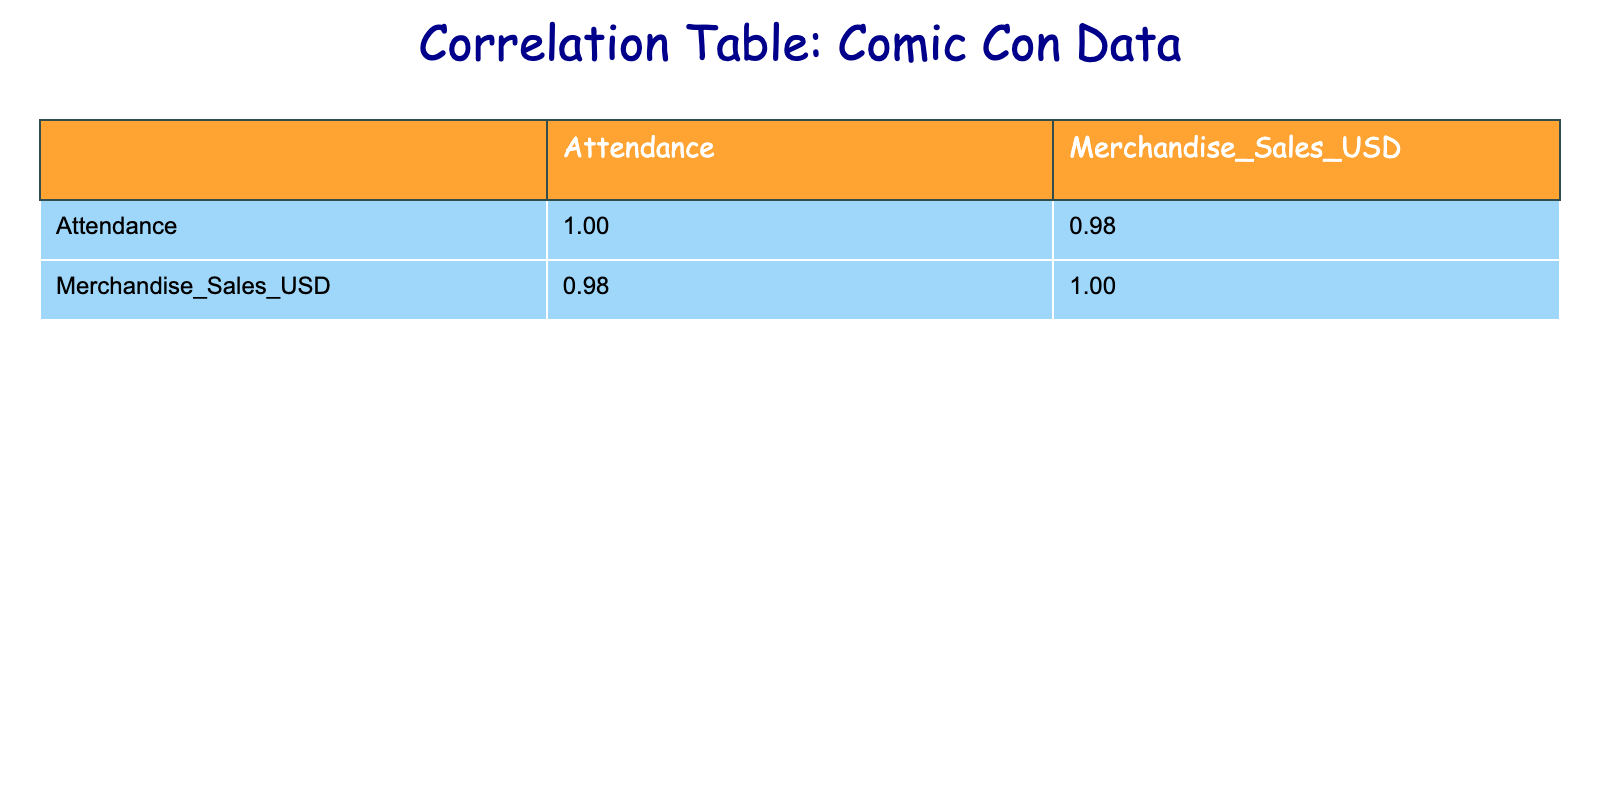What is the merchandise sales for Anime Expo? The table shows the Merchandise Sales USD for Anime Expo directly, listed as 1700000.
Answer: 1700000 Which convention had the highest attendance? By looking at the Attendance column, New York Comic Con shows the highest attendance at 150000.
Answer: New York Comic Con What is the total merchandise sales for conventions with attendance over 100000? We check the Attendance column for values greater than 100000: Comic-Con International (2000000), New York Comic Con (2500000), and Anime Expo (1700000). Summing these sales yields: 2000000 + 2500000 + 1700000 = 6200000.
Answer: 6200000 Is it true that San Diego Comic Fest had higher merchandise sales than Baltimore Comic-Con? San Diego Comic Fest has merchandise sales of 250000, while Baltimore Comic-Con has sales of 400000. Comparing these values, San Diego Comic Fest did not exceed Baltimore Comic-Con's sales.
Answer: No What is the average merchandise sales for conventions with attendance below 50000? The only convention with attendance below 50000 is Phoenix Fan Fusion, which has merchandise sales of 700000. Since there's just one data point, the average is the same as the sales for this convention, which is 700000.
Answer: 700000 Which two conventions had similar attendance numbers? Examining the Attendance column, LA Comic Con has 75000 while Fan Expo Dallas has 80000, making their attendance numbers relatively close compared to others.
Answer: LA Comic Con and Fan Expo Dallas What is the difference in merchandise sales between the convention with the lowest and highest attendance? The convention with the lowest attendance is San Diego Comic Fest with sales of 250000, and the highest is New York Comic Con with sales of 2500000. The difference in sales is calculated by subtracting these two values: 2500000 - 250000 = 2250000.
Answer: 2250000 How many conventions had attendance numbers between 50000 and 100000? From the table, conventions that fall into this range are Emerald City Comic Con (100000), Anime Expo (100000), and Fan Expo Dallas (80000). In total, there are 4 conventions: Emerald City Comic Con, Anime Expo, LA Comic Con, and Fan Expo Dallas.
Answer: 4 What is the correlation between attendance and merchandise sales? To determine the correlation between these two variables, we observe the correlation matrix in the table where the correlation value between Attendance and Merchandise Sales is presented. Let's say the value is positive, indicating a direct correlation; however, the exact value would need to be looked at from the table.
Answer: Positive correlation 